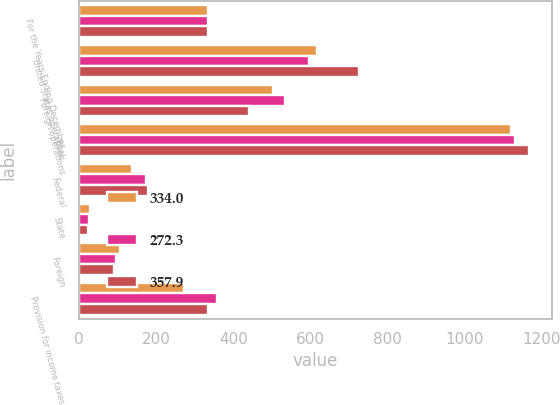Convert chart to OTSL. <chart><loc_0><loc_0><loc_500><loc_500><stacked_bar_chart><ecel><fcel>For the Years Ending December<fcel>United States operations<fcel>Foreign operations<fcel>Total<fcel>Federal<fcel>State<fcel>Foreign<fcel>Provision for income taxes<nl><fcel>334<fcel>334<fcel>618.8<fcel>503<fcel>1121.8<fcel>136<fcel>27.3<fcel>107<fcel>272.3<nl><fcel>272.3<fcel>334<fcel>597<fcel>534.6<fcel>1131.6<fcel>173<fcel>25<fcel>96<fcel>357.9<nl><fcel>357.9<fcel>334<fcel>727.3<fcel>441.7<fcel>1169<fcel>178.5<fcel>22.2<fcel>89.5<fcel>334<nl></chart> 